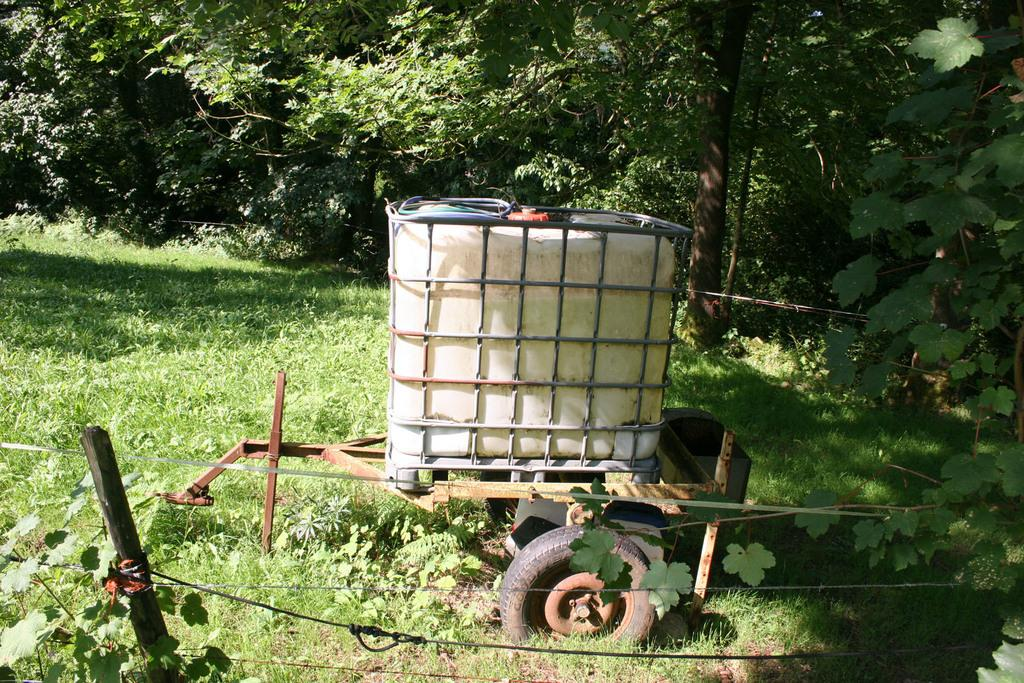What is the main object on the cart in the image? There is a container closed with grills on a cart. How is the container positioned in the image? The container is on a cart. What is used to secure the poles in the image? Poles are tied with rope. What type of vegetation can be seen in the image? There is some grass visible in the image, as well as plants and a group of trees. What type of finger can be seen holding the expert's hand in the image? There is no finger or expert present in the image. 